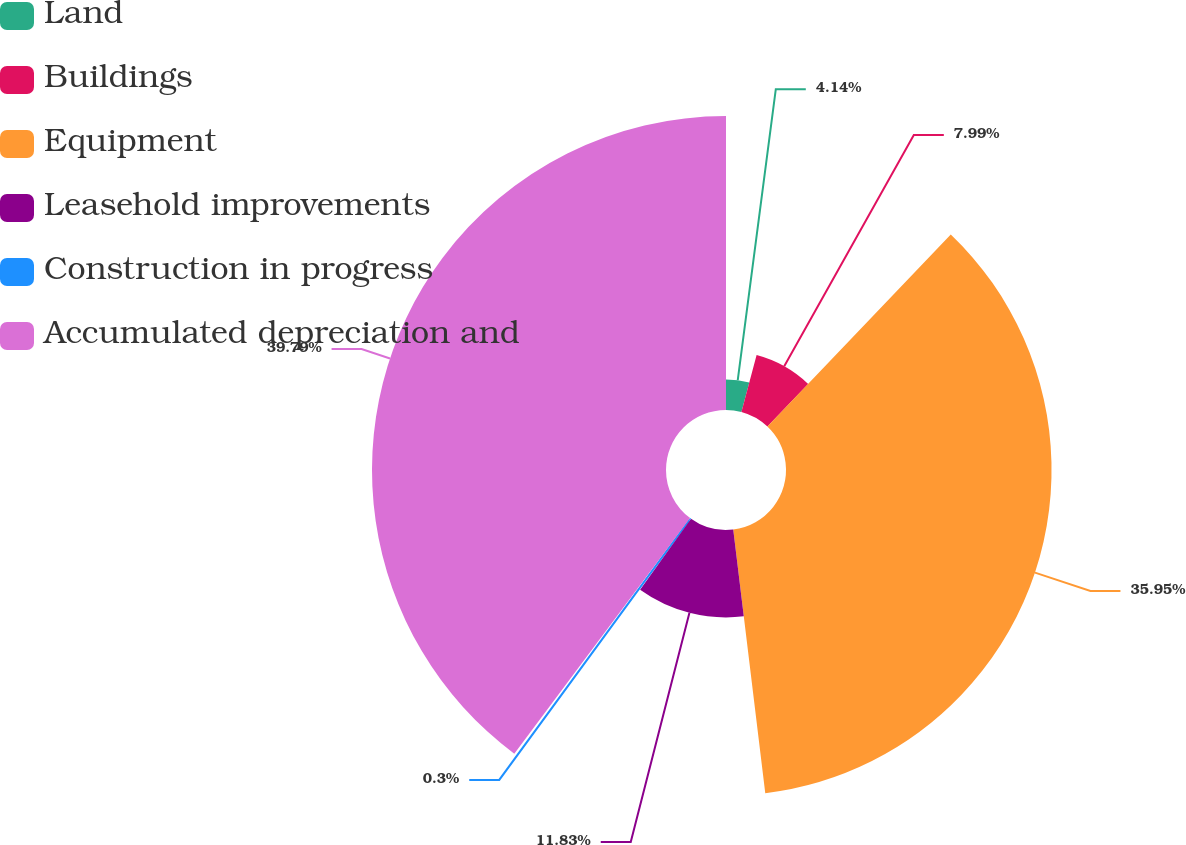Convert chart. <chart><loc_0><loc_0><loc_500><loc_500><pie_chart><fcel>Land<fcel>Buildings<fcel>Equipment<fcel>Leasehold improvements<fcel>Construction in progress<fcel>Accumulated depreciation and<nl><fcel>4.14%<fcel>7.99%<fcel>35.95%<fcel>11.83%<fcel>0.3%<fcel>39.8%<nl></chart> 